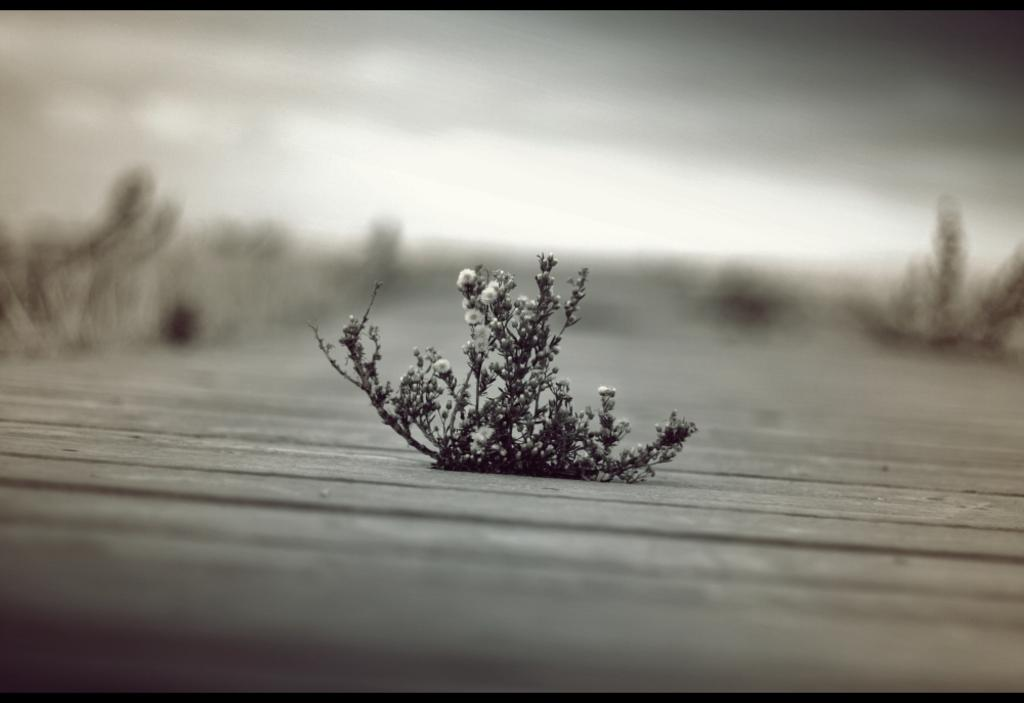What is the color scheme of the image? The image is black and white. What type of plant can be seen in the image? There is a flower plant in the image. What type of soda is being poured into the flower plant in the image? There is no soda present in the image; it features a black and white flower plant. Can you see a tiger hiding behind the flower plant in the image? There is no tiger present in the image; it only features a flower plant. 